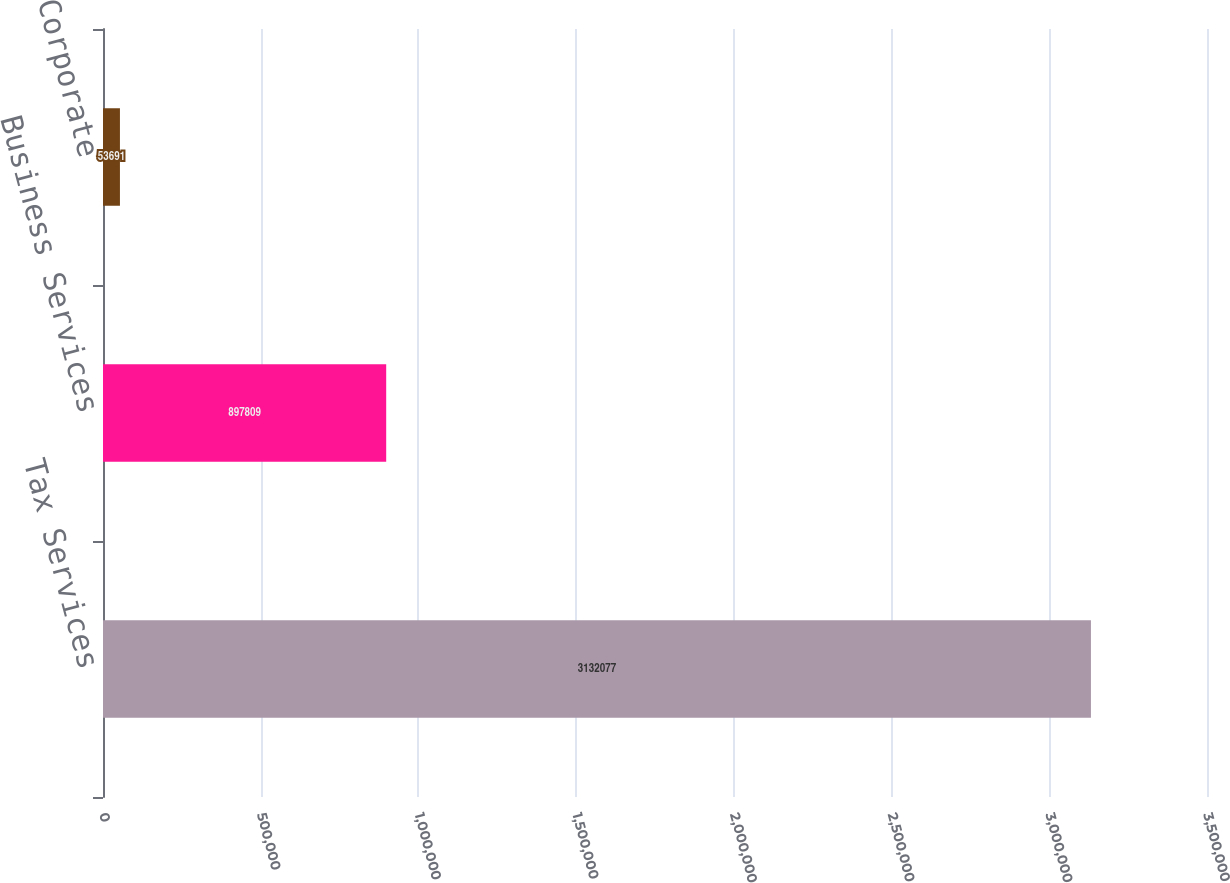Convert chart to OTSL. <chart><loc_0><loc_0><loc_500><loc_500><bar_chart><fcel>Tax Services<fcel>Business Services<fcel>Corporate<nl><fcel>3.13208e+06<fcel>897809<fcel>53691<nl></chart> 